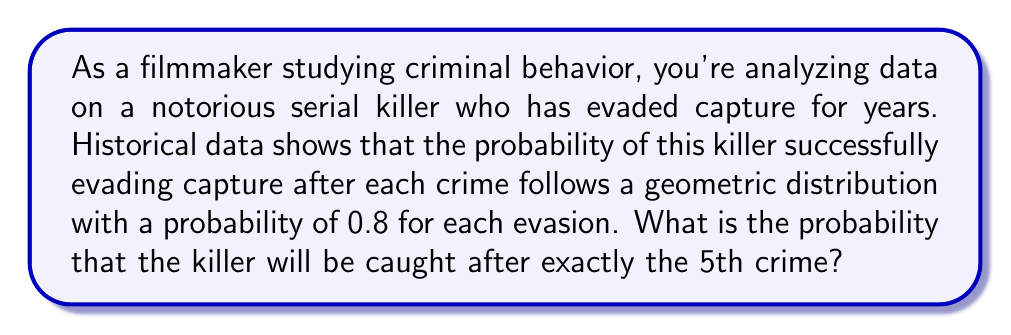Give your solution to this math problem. To solve this problem, we'll use the geometric distribution formula. The geometric distribution models the number of successes (in this case, evasions) before the first failure (capture).

1) The probability mass function for a geometric distribution is:
   $$P(X = k) = (1-p)p^{k-1}$$
   where $p$ is the probability of success on each trial, and $k$ is the number of trials until the first failure.

2) In this case:
   $p = 0.8$ (probability of evading capture each time)
   $k = 5$ (we want the probability of being caught after exactly the 5th crime)

3) We need to calculate $P(X = 5)$:
   $$P(X = 5) = (1-0.8)(0.8)^{5-1}$$

4) Simplify:
   $$P(X = 5) = (0.2)(0.8)^4$$

5) Calculate:
   $$P(X = 5) = 0.2 * 0.4096 = 0.08192$$

6) Convert to a percentage:
   $$0.08192 * 100\% = 8.192\%$$
Answer: 8.192% 